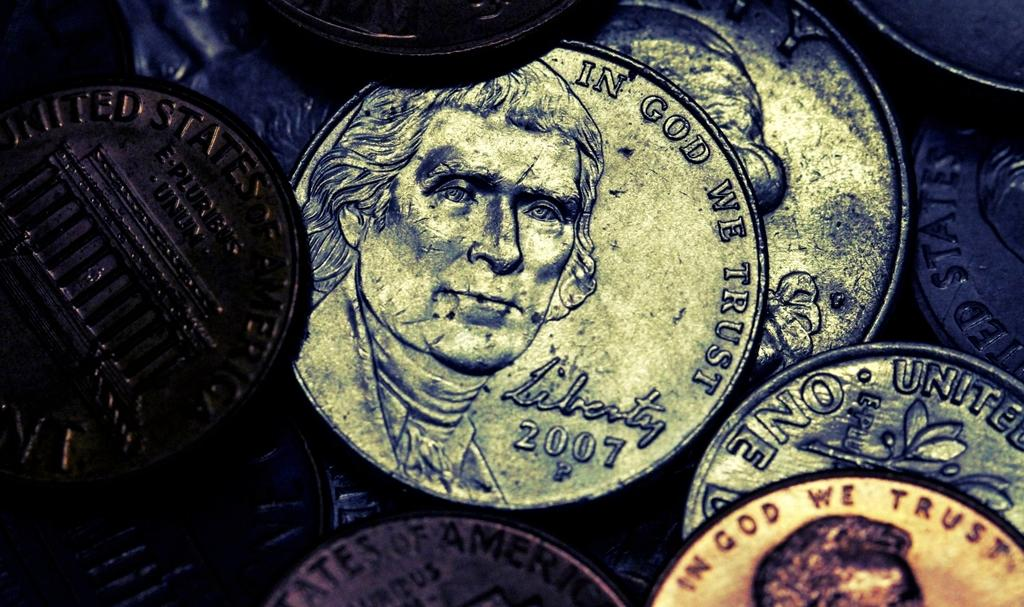<image>
Give a short and clear explanation of the subsequent image. many coins are laying together, including a 2007 Liberty coin 